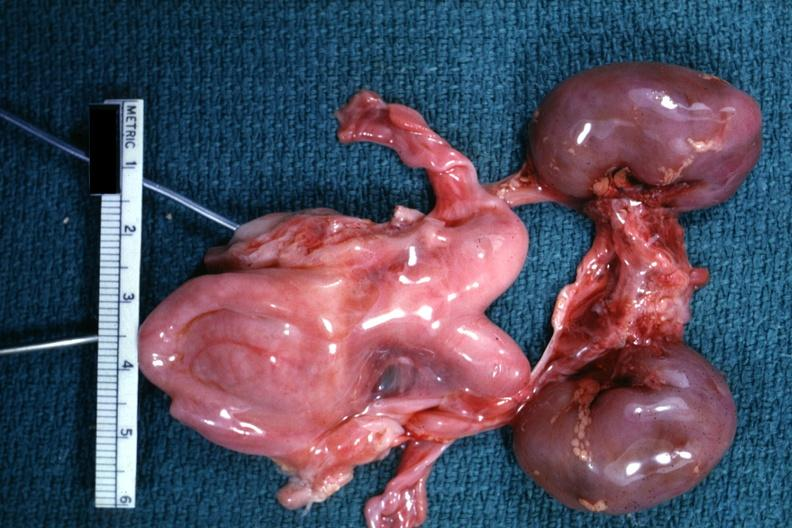s fibrinous peritonitis present?
Answer the question using a single word or phrase. No 